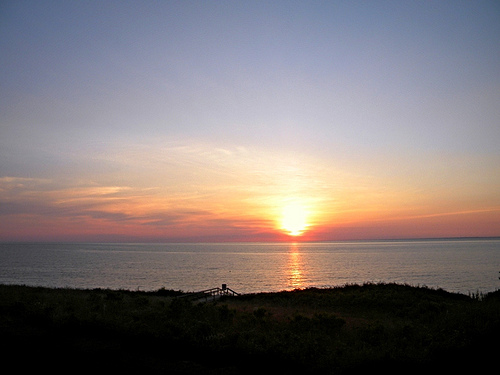<image>
Is there a sun in the water? No. The sun is not contained within the water. These objects have a different spatial relationship. Is there a cloud above the water? Yes. The cloud is positioned above the water in the vertical space, higher up in the scene. 